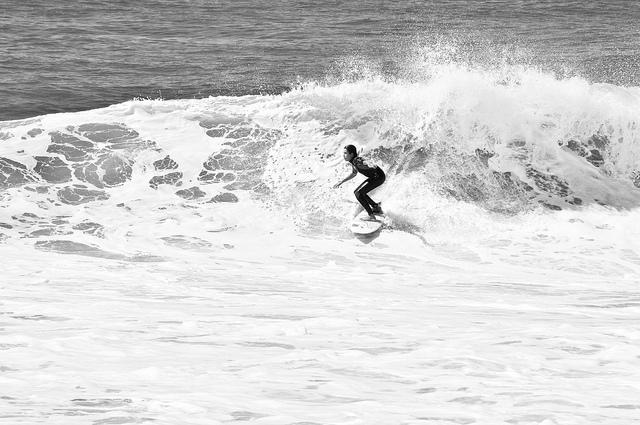Is this scene a clip from the movie titanic?
Short answer required. No. What is crashing in the background?
Be succinct. Waves. What is the person doing?
Write a very short answer. Surfing. 